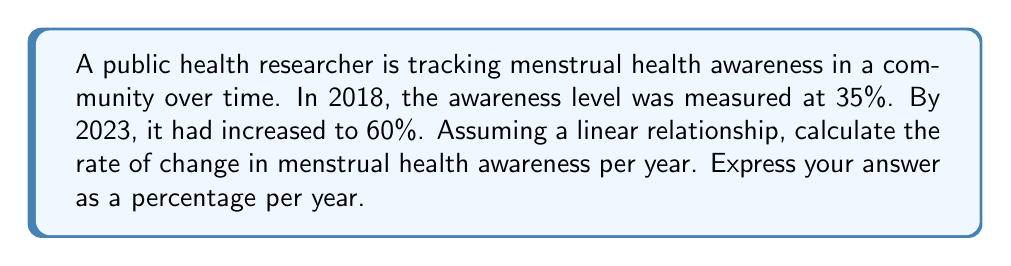Help me with this question. To solve this problem, we'll use the linear equation formula:

$$y = mx + b$$

Where:
$m$ is the slope (rate of change)
$x$ is the time in years
$b$ is the y-intercept (initial awareness level)

Given:
- Initial awareness (2018): 35%
- Final awareness (2023): 60%
- Time span: 5 years

Step 1: Calculate the change in awareness
$$\Delta y = 60\% - 35\% = 25\%$$

Step 2: Calculate the change in time
$$\Delta x = 2023 - 2018 = 5 \text{ years}$$

Step 3: Calculate the slope (rate of change)
$$m = \frac{\Delta y}{\Delta x} = \frac{25\%}{5 \text{ years}} = 5\% \text{ per year}$$

Therefore, the rate of change in menstrual health awareness is 5% per year.
Answer: 5% per year 